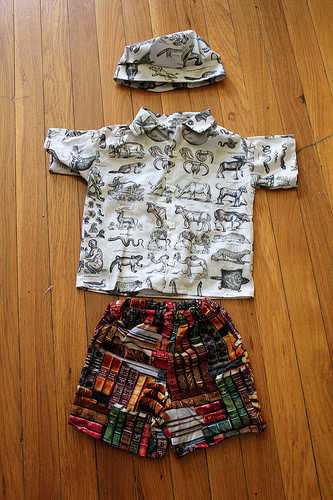<image>
Is there a hat on the shirt? No. The hat is not positioned on the shirt. They may be near each other, but the hat is not supported by or resting on top of the shirt. 